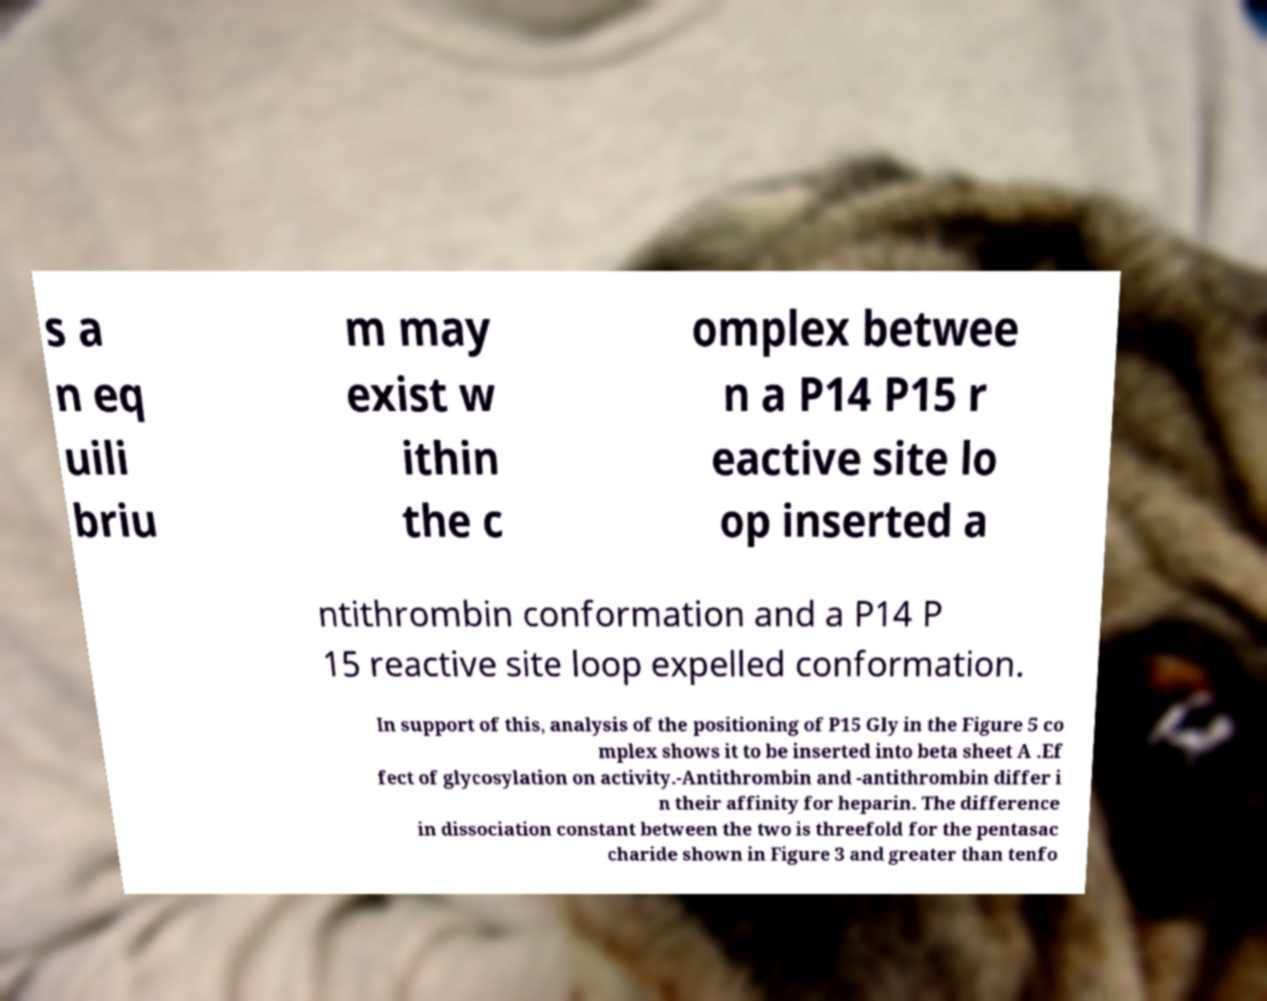I need the written content from this picture converted into text. Can you do that? s a n eq uili briu m may exist w ithin the c omplex betwee n a P14 P15 r eactive site lo op inserted a ntithrombin conformation and a P14 P 15 reactive site loop expelled conformation. In support of this, analysis of the positioning of P15 Gly in the Figure 5 co mplex shows it to be inserted into beta sheet A .Ef fect of glycosylation on activity.-Antithrombin and -antithrombin differ i n their affinity for heparin. The difference in dissociation constant between the two is threefold for the pentasac charide shown in Figure 3 and greater than tenfo 